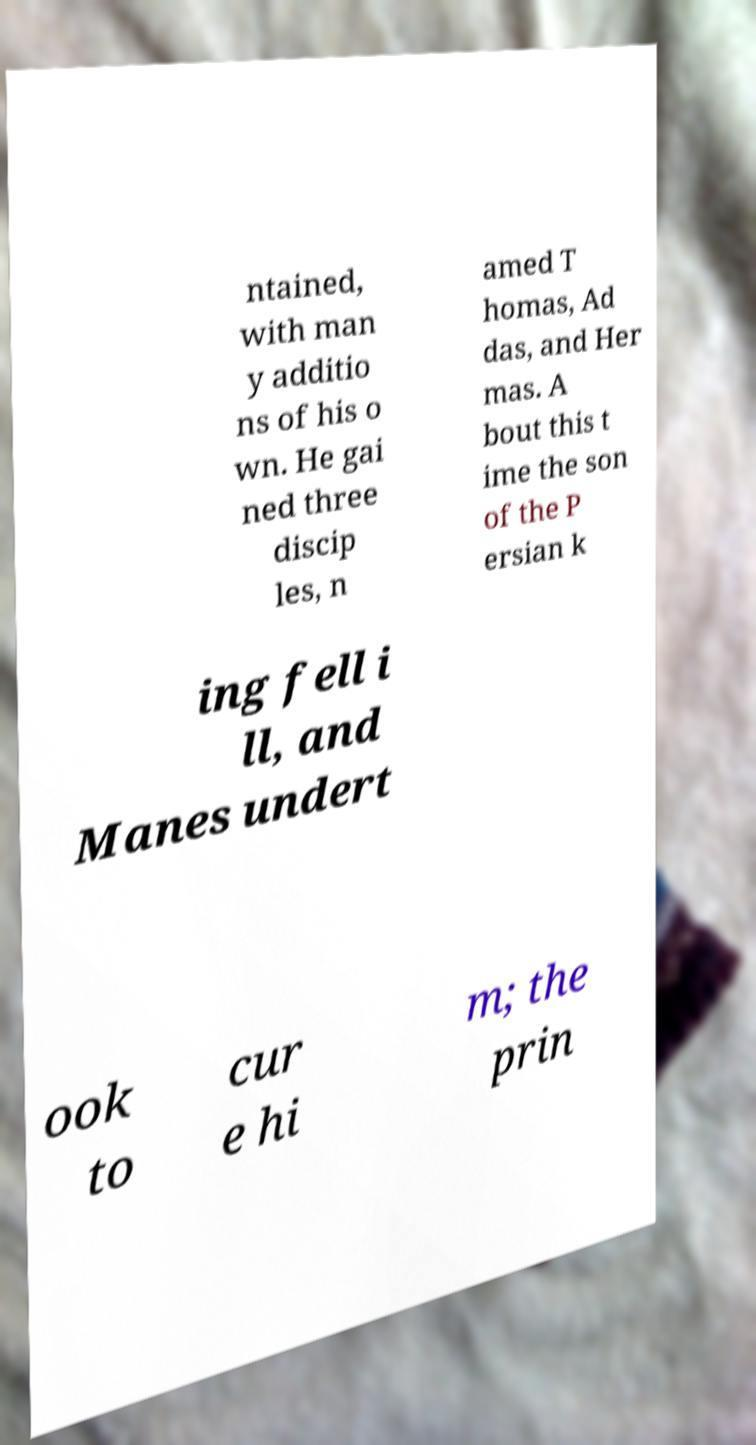There's text embedded in this image that I need extracted. Can you transcribe it verbatim? ntained, with man y additio ns of his o wn. He gai ned three discip les, n amed T homas, Ad das, and Her mas. A bout this t ime the son of the P ersian k ing fell i ll, and Manes undert ook to cur e hi m; the prin 